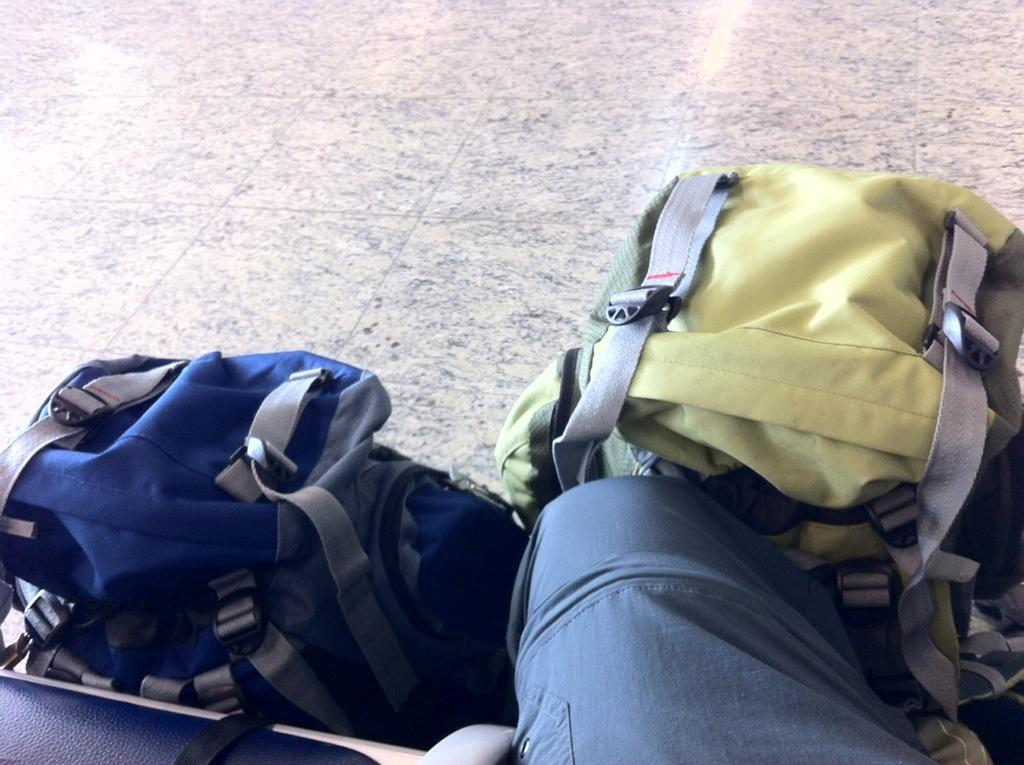What is the person in the image doing? The person is sitting on the floor. What else can be seen in the image besides the person? There are traveling bags in the image. Is the person in the image sinking into quicksand? No, there is no quicksand present in the image. What type of art can be seen hanging on the wall in the image? There is no art or wall visible in the image; it only shows a person sitting on the floor and traveling bags. 